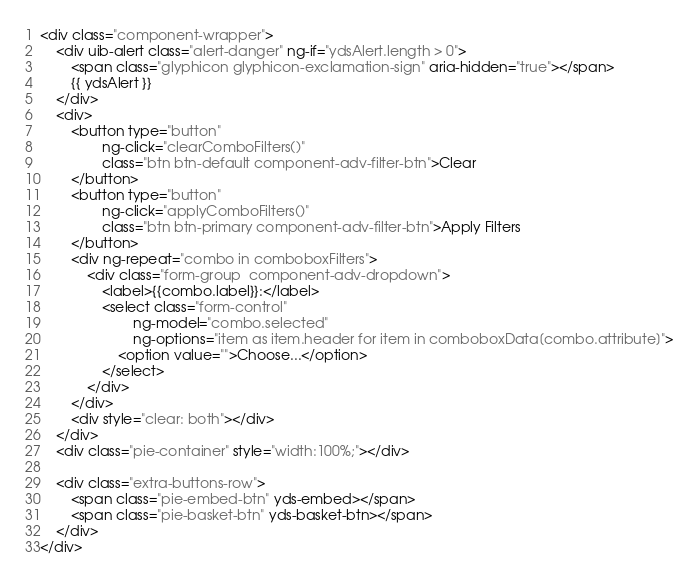Convert code to text. <code><loc_0><loc_0><loc_500><loc_500><_HTML_><div class="component-wrapper">
    <div uib-alert class="alert-danger" ng-if="ydsAlert.length > 0">
        <span class="glyphicon glyphicon-exclamation-sign" aria-hidden="true"></span>
        {{ ydsAlert }}
    </div>
    <div>
        <button type="button"
                ng-click="clearComboFilters()"
                class="btn btn-default component-adv-filter-btn">Clear
        </button>
        <button type="button"
                ng-click="applyComboFilters()"
                class="btn btn-primary component-adv-filter-btn">Apply Filters
        </button>
        <div ng-repeat="combo in comboboxFilters">
            <div class="form-group  component-adv-dropdown">
                <label>{{combo.label}}:</label>
                <select class="form-control"
                        ng-model="combo.selected"
                        ng-options="item as item.header for item in comboboxData[combo.attribute]">
                    <option value="">Choose...</option>
                </select>
            </div>
        </div>
        <div style="clear: both"></div>
    </div>
    <div class="pie-container" style="width:100%;"></div>

    <div class="extra-buttons-row">
        <span class="pie-embed-btn" yds-embed></span>
        <span class="pie-basket-btn" yds-basket-btn></span>
    </div>
</div></code> 